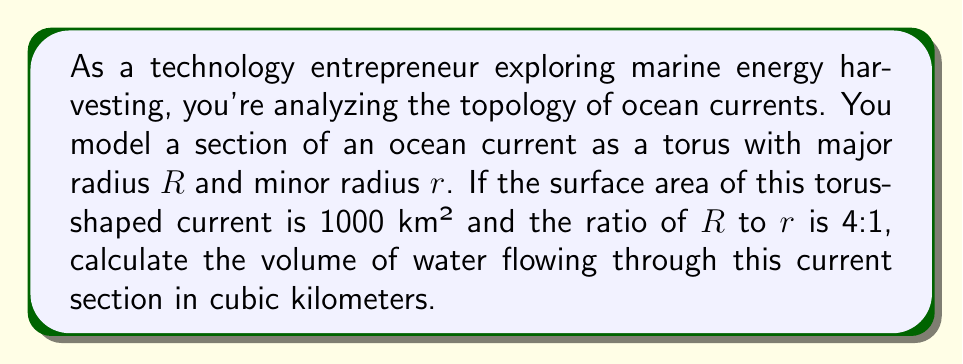What is the answer to this math problem? Let's approach this step-by-step:

1) The surface area of a torus is given by the formula:
   $$A = 4\pi^2Rr$$

2) We're given that the surface area is 1000 km², so:
   $$1000 = 4\pi^2Rr$$

3) We're also told that $R:r = 4:1$, which means $R = 4r$. Let's substitute this into our equation:
   $$1000 = 4\pi^2(4r)r = 16\pi^2r^2$$

4) Now we can solve for $r$:
   $$r^2 = \frac{1000}{16\pi^2}$$
   $$r = \sqrt{\frac{1000}{16\pi^2}} \approx 3.989 \text{ km}$$

5) Since $R = 4r$, we can calculate $R$:
   $$R \approx 15.956 \text{ km}$$

6) The volume of a torus is given by the formula:
   $$V = 2\pi^2Rr^2$$

7) Let's substitute our values:
   $$V = 2\pi^2(15.956)(3.989^2)$$

8) Calculating this:
   $$V \approx 3980.884 \text{ km}^3$$
Answer: The volume of water flowing through this current section is approximately 3980.9 km³. 